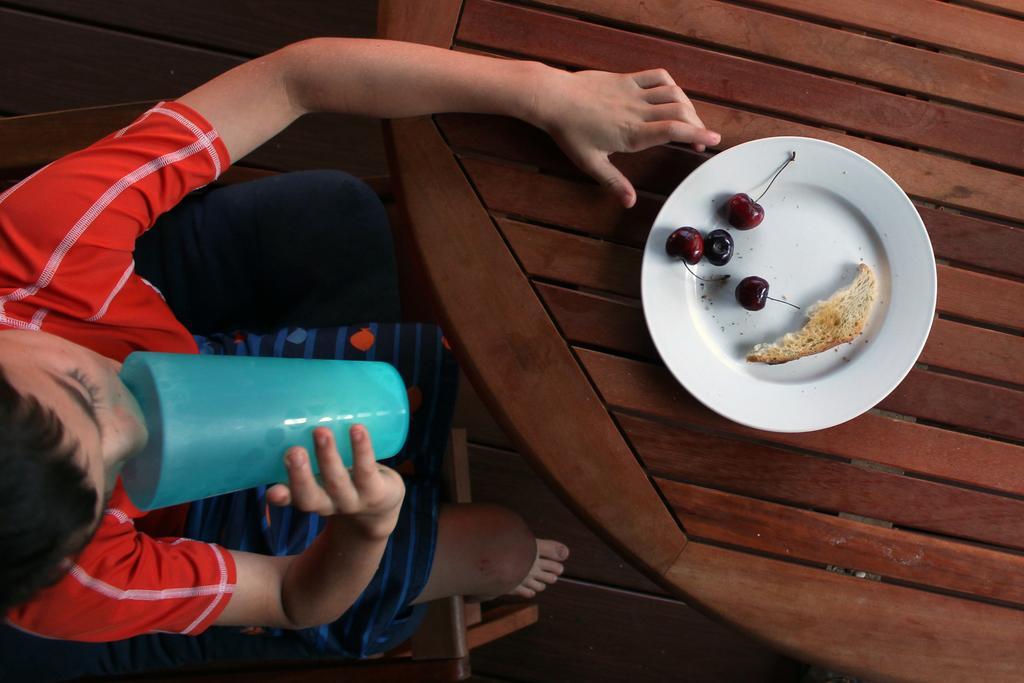Could you give a brief overview of what you see in this image? In this image, there are cherries and a bread slice in the plate placed on the table, and we can see a boy holding glass in his hand and drinking water and sitting on the chair. 